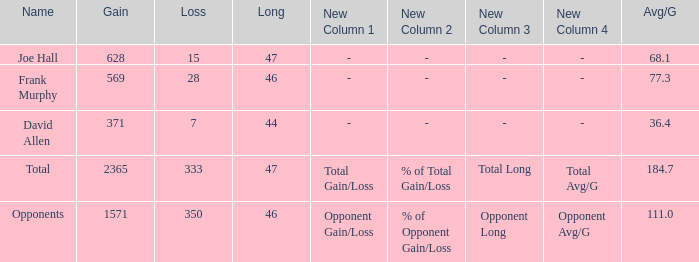Which Avg/G is the lowest one that has a Long smaller than 47, and a Name of frank murphy, and a Gain smaller than 569? None. 